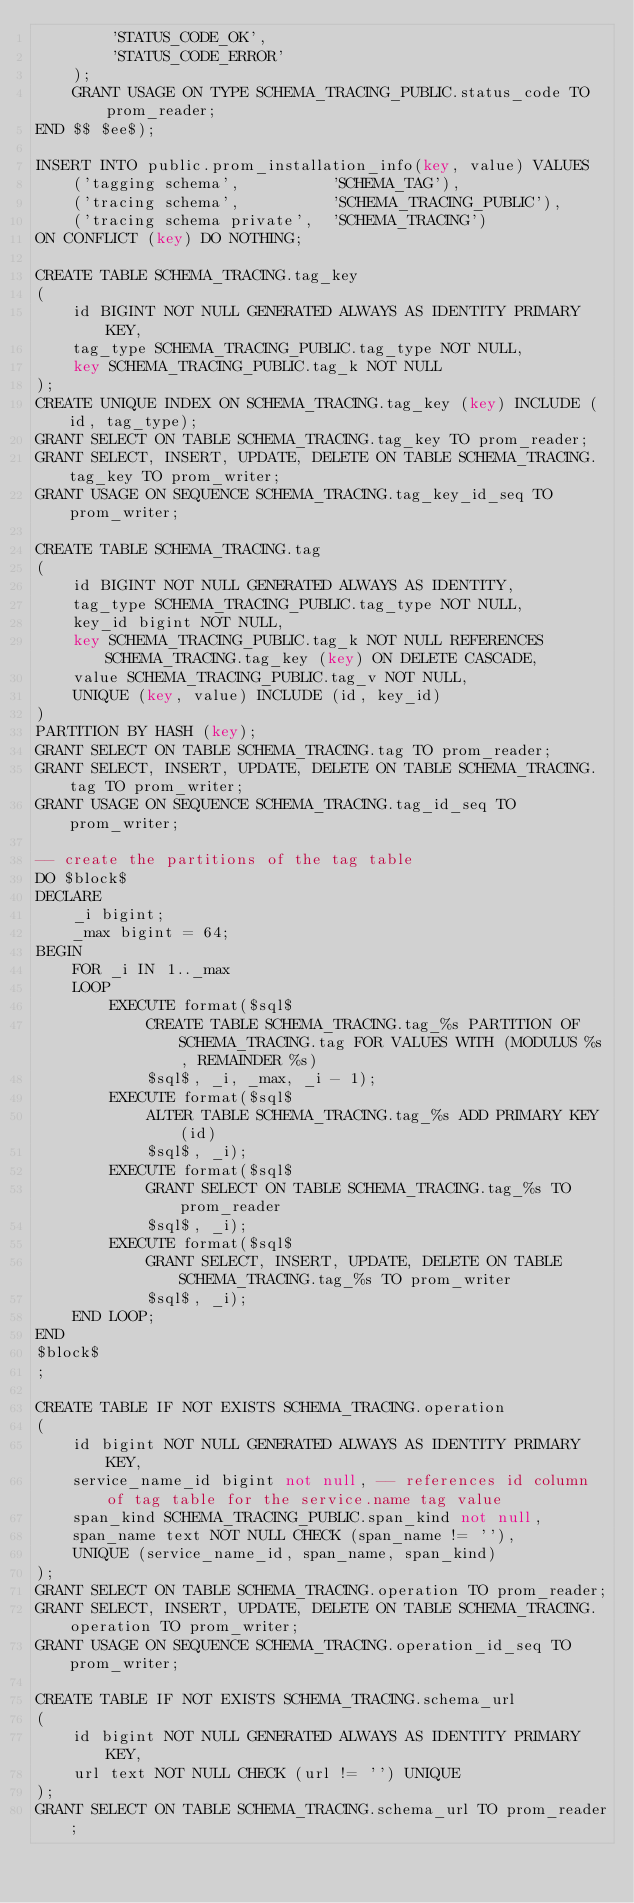<code> <loc_0><loc_0><loc_500><loc_500><_SQL_>        'STATUS_CODE_OK',
        'STATUS_CODE_ERROR'
    );
    GRANT USAGE ON TYPE SCHEMA_TRACING_PUBLIC.status_code TO prom_reader;
END $$ $ee$);

INSERT INTO public.prom_installation_info(key, value) VALUES
    ('tagging schema',          'SCHEMA_TAG'),
    ('tracing schema',          'SCHEMA_TRACING_PUBLIC'),
    ('tracing schema private',  'SCHEMA_TRACING')
ON CONFLICT (key) DO NOTHING;

CREATE TABLE SCHEMA_TRACING.tag_key
(
    id BIGINT NOT NULL GENERATED ALWAYS AS IDENTITY PRIMARY KEY,
    tag_type SCHEMA_TRACING_PUBLIC.tag_type NOT NULL,
    key SCHEMA_TRACING_PUBLIC.tag_k NOT NULL
);
CREATE UNIQUE INDEX ON SCHEMA_TRACING.tag_key (key) INCLUDE (id, tag_type);
GRANT SELECT ON TABLE SCHEMA_TRACING.tag_key TO prom_reader;
GRANT SELECT, INSERT, UPDATE, DELETE ON TABLE SCHEMA_TRACING.tag_key TO prom_writer;
GRANT USAGE ON SEQUENCE SCHEMA_TRACING.tag_key_id_seq TO prom_writer;

CREATE TABLE SCHEMA_TRACING.tag
(
    id BIGINT NOT NULL GENERATED ALWAYS AS IDENTITY,
    tag_type SCHEMA_TRACING_PUBLIC.tag_type NOT NULL,
    key_id bigint NOT NULL,
    key SCHEMA_TRACING_PUBLIC.tag_k NOT NULL REFERENCES SCHEMA_TRACING.tag_key (key) ON DELETE CASCADE,
    value SCHEMA_TRACING_PUBLIC.tag_v NOT NULL,
    UNIQUE (key, value) INCLUDE (id, key_id)
)
PARTITION BY HASH (key);
GRANT SELECT ON TABLE SCHEMA_TRACING.tag TO prom_reader;
GRANT SELECT, INSERT, UPDATE, DELETE ON TABLE SCHEMA_TRACING.tag TO prom_writer;
GRANT USAGE ON SEQUENCE SCHEMA_TRACING.tag_id_seq TO prom_writer;

-- create the partitions of the tag table
DO $block$
DECLARE
    _i bigint;
    _max bigint = 64;
BEGIN
    FOR _i IN 1.._max
    LOOP
        EXECUTE format($sql$
            CREATE TABLE SCHEMA_TRACING.tag_%s PARTITION OF SCHEMA_TRACING.tag FOR VALUES WITH (MODULUS %s, REMAINDER %s)
            $sql$, _i, _max, _i - 1);
        EXECUTE format($sql$
            ALTER TABLE SCHEMA_TRACING.tag_%s ADD PRIMARY KEY (id)
            $sql$, _i);
        EXECUTE format($sql$
            GRANT SELECT ON TABLE SCHEMA_TRACING.tag_%s TO prom_reader
            $sql$, _i);
        EXECUTE format($sql$
            GRANT SELECT, INSERT, UPDATE, DELETE ON TABLE SCHEMA_TRACING.tag_%s TO prom_writer
            $sql$, _i);
    END LOOP;
END
$block$
;

CREATE TABLE IF NOT EXISTS SCHEMA_TRACING.operation
(
    id bigint NOT NULL GENERATED ALWAYS AS IDENTITY PRIMARY KEY,
    service_name_id bigint not null, -- references id column of tag table for the service.name tag value
    span_kind SCHEMA_TRACING_PUBLIC.span_kind not null,
    span_name text NOT NULL CHECK (span_name != ''),
    UNIQUE (service_name_id, span_name, span_kind)
);
GRANT SELECT ON TABLE SCHEMA_TRACING.operation TO prom_reader;
GRANT SELECT, INSERT, UPDATE, DELETE ON TABLE SCHEMA_TRACING.operation TO prom_writer;
GRANT USAGE ON SEQUENCE SCHEMA_TRACING.operation_id_seq TO prom_writer;

CREATE TABLE IF NOT EXISTS SCHEMA_TRACING.schema_url
(
    id bigint NOT NULL GENERATED ALWAYS AS IDENTITY PRIMARY KEY,
    url text NOT NULL CHECK (url != '') UNIQUE
);
GRANT SELECT ON TABLE SCHEMA_TRACING.schema_url TO prom_reader;</code> 